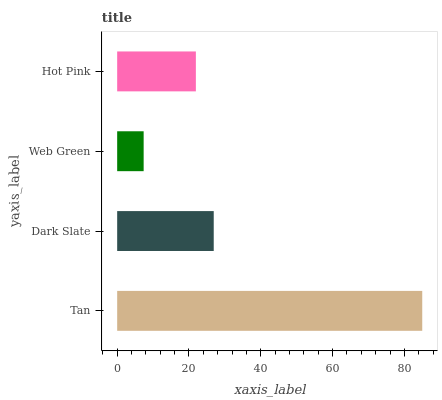Is Web Green the minimum?
Answer yes or no. Yes. Is Tan the maximum?
Answer yes or no. Yes. Is Dark Slate the minimum?
Answer yes or no. No. Is Dark Slate the maximum?
Answer yes or no. No. Is Tan greater than Dark Slate?
Answer yes or no. Yes. Is Dark Slate less than Tan?
Answer yes or no. Yes. Is Dark Slate greater than Tan?
Answer yes or no. No. Is Tan less than Dark Slate?
Answer yes or no. No. Is Dark Slate the high median?
Answer yes or no. Yes. Is Hot Pink the low median?
Answer yes or no. Yes. Is Web Green the high median?
Answer yes or no. No. Is Tan the low median?
Answer yes or no. No. 